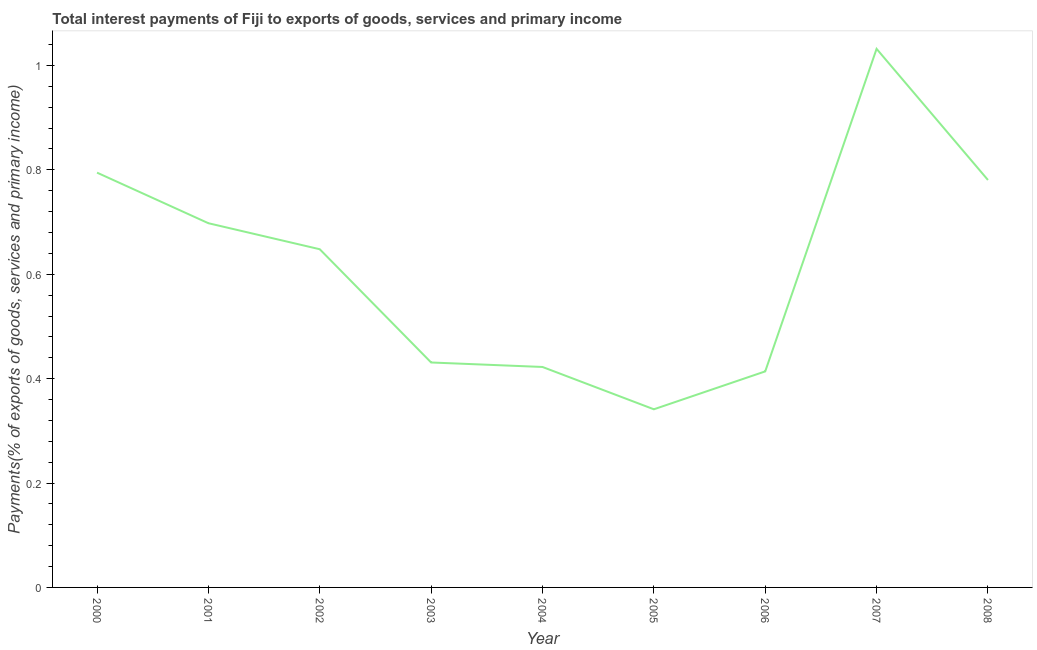What is the total interest payments on external debt in 2006?
Provide a short and direct response. 0.41. Across all years, what is the maximum total interest payments on external debt?
Provide a succinct answer. 1.03. Across all years, what is the minimum total interest payments on external debt?
Your answer should be very brief. 0.34. In which year was the total interest payments on external debt maximum?
Your response must be concise. 2007. In which year was the total interest payments on external debt minimum?
Give a very brief answer. 2005. What is the sum of the total interest payments on external debt?
Make the answer very short. 5.56. What is the difference between the total interest payments on external debt in 2000 and 2004?
Offer a terse response. 0.37. What is the average total interest payments on external debt per year?
Your answer should be compact. 0.62. What is the median total interest payments on external debt?
Offer a terse response. 0.65. What is the ratio of the total interest payments on external debt in 2000 to that in 2004?
Offer a terse response. 1.88. Is the difference between the total interest payments on external debt in 2001 and 2002 greater than the difference between any two years?
Your response must be concise. No. What is the difference between the highest and the second highest total interest payments on external debt?
Give a very brief answer. 0.24. What is the difference between the highest and the lowest total interest payments on external debt?
Keep it short and to the point. 0.69. In how many years, is the total interest payments on external debt greater than the average total interest payments on external debt taken over all years?
Provide a short and direct response. 5. How many lines are there?
Offer a terse response. 1. What is the difference between two consecutive major ticks on the Y-axis?
Your answer should be very brief. 0.2. Are the values on the major ticks of Y-axis written in scientific E-notation?
Provide a succinct answer. No. Does the graph contain any zero values?
Provide a short and direct response. No. Does the graph contain grids?
Ensure brevity in your answer.  No. What is the title of the graph?
Your answer should be very brief. Total interest payments of Fiji to exports of goods, services and primary income. What is the label or title of the Y-axis?
Your answer should be compact. Payments(% of exports of goods, services and primary income). What is the Payments(% of exports of goods, services and primary income) of 2000?
Your response must be concise. 0.79. What is the Payments(% of exports of goods, services and primary income) in 2001?
Provide a succinct answer. 0.7. What is the Payments(% of exports of goods, services and primary income) of 2002?
Your response must be concise. 0.65. What is the Payments(% of exports of goods, services and primary income) in 2003?
Provide a short and direct response. 0.43. What is the Payments(% of exports of goods, services and primary income) of 2004?
Provide a succinct answer. 0.42. What is the Payments(% of exports of goods, services and primary income) of 2005?
Your answer should be very brief. 0.34. What is the Payments(% of exports of goods, services and primary income) in 2006?
Keep it short and to the point. 0.41. What is the Payments(% of exports of goods, services and primary income) of 2007?
Your answer should be very brief. 1.03. What is the Payments(% of exports of goods, services and primary income) of 2008?
Make the answer very short. 0.78. What is the difference between the Payments(% of exports of goods, services and primary income) in 2000 and 2001?
Provide a succinct answer. 0.1. What is the difference between the Payments(% of exports of goods, services and primary income) in 2000 and 2002?
Provide a succinct answer. 0.15. What is the difference between the Payments(% of exports of goods, services and primary income) in 2000 and 2003?
Your response must be concise. 0.36. What is the difference between the Payments(% of exports of goods, services and primary income) in 2000 and 2004?
Your response must be concise. 0.37. What is the difference between the Payments(% of exports of goods, services and primary income) in 2000 and 2005?
Give a very brief answer. 0.45. What is the difference between the Payments(% of exports of goods, services and primary income) in 2000 and 2006?
Provide a succinct answer. 0.38. What is the difference between the Payments(% of exports of goods, services and primary income) in 2000 and 2007?
Your answer should be compact. -0.24. What is the difference between the Payments(% of exports of goods, services and primary income) in 2000 and 2008?
Keep it short and to the point. 0.01. What is the difference between the Payments(% of exports of goods, services and primary income) in 2001 and 2002?
Keep it short and to the point. 0.05. What is the difference between the Payments(% of exports of goods, services and primary income) in 2001 and 2003?
Offer a terse response. 0.27. What is the difference between the Payments(% of exports of goods, services and primary income) in 2001 and 2004?
Offer a terse response. 0.28. What is the difference between the Payments(% of exports of goods, services and primary income) in 2001 and 2005?
Offer a very short reply. 0.36. What is the difference between the Payments(% of exports of goods, services and primary income) in 2001 and 2006?
Provide a short and direct response. 0.28. What is the difference between the Payments(% of exports of goods, services and primary income) in 2001 and 2007?
Make the answer very short. -0.33. What is the difference between the Payments(% of exports of goods, services and primary income) in 2001 and 2008?
Offer a very short reply. -0.08. What is the difference between the Payments(% of exports of goods, services and primary income) in 2002 and 2003?
Make the answer very short. 0.22. What is the difference between the Payments(% of exports of goods, services and primary income) in 2002 and 2004?
Provide a succinct answer. 0.23. What is the difference between the Payments(% of exports of goods, services and primary income) in 2002 and 2005?
Your answer should be compact. 0.31. What is the difference between the Payments(% of exports of goods, services and primary income) in 2002 and 2006?
Your answer should be very brief. 0.23. What is the difference between the Payments(% of exports of goods, services and primary income) in 2002 and 2007?
Your answer should be very brief. -0.38. What is the difference between the Payments(% of exports of goods, services and primary income) in 2002 and 2008?
Make the answer very short. -0.13. What is the difference between the Payments(% of exports of goods, services and primary income) in 2003 and 2004?
Your answer should be compact. 0.01. What is the difference between the Payments(% of exports of goods, services and primary income) in 2003 and 2005?
Give a very brief answer. 0.09. What is the difference between the Payments(% of exports of goods, services and primary income) in 2003 and 2006?
Give a very brief answer. 0.02. What is the difference between the Payments(% of exports of goods, services and primary income) in 2003 and 2007?
Your response must be concise. -0.6. What is the difference between the Payments(% of exports of goods, services and primary income) in 2003 and 2008?
Give a very brief answer. -0.35. What is the difference between the Payments(% of exports of goods, services and primary income) in 2004 and 2005?
Your answer should be compact. 0.08. What is the difference between the Payments(% of exports of goods, services and primary income) in 2004 and 2006?
Ensure brevity in your answer.  0.01. What is the difference between the Payments(% of exports of goods, services and primary income) in 2004 and 2007?
Provide a succinct answer. -0.61. What is the difference between the Payments(% of exports of goods, services and primary income) in 2004 and 2008?
Provide a short and direct response. -0.36. What is the difference between the Payments(% of exports of goods, services and primary income) in 2005 and 2006?
Your response must be concise. -0.07. What is the difference between the Payments(% of exports of goods, services and primary income) in 2005 and 2007?
Your answer should be compact. -0.69. What is the difference between the Payments(% of exports of goods, services and primary income) in 2005 and 2008?
Provide a short and direct response. -0.44. What is the difference between the Payments(% of exports of goods, services and primary income) in 2006 and 2007?
Your response must be concise. -0.62. What is the difference between the Payments(% of exports of goods, services and primary income) in 2006 and 2008?
Give a very brief answer. -0.37. What is the difference between the Payments(% of exports of goods, services and primary income) in 2007 and 2008?
Offer a terse response. 0.25. What is the ratio of the Payments(% of exports of goods, services and primary income) in 2000 to that in 2001?
Provide a succinct answer. 1.14. What is the ratio of the Payments(% of exports of goods, services and primary income) in 2000 to that in 2002?
Keep it short and to the point. 1.23. What is the ratio of the Payments(% of exports of goods, services and primary income) in 2000 to that in 2003?
Give a very brief answer. 1.84. What is the ratio of the Payments(% of exports of goods, services and primary income) in 2000 to that in 2004?
Keep it short and to the point. 1.88. What is the ratio of the Payments(% of exports of goods, services and primary income) in 2000 to that in 2005?
Your answer should be very brief. 2.33. What is the ratio of the Payments(% of exports of goods, services and primary income) in 2000 to that in 2006?
Keep it short and to the point. 1.92. What is the ratio of the Payments(% of exports of goods, services and primary income) in 2000 to that in 2007?
Keep it short and to the point. 0.77. What is the ratio of the Payments(% of exports of goods, services and primary income) in 2001 to that in 2002?
Keep it short and to the point. 1.08. What is the ratio of the Payments(% of exports of goods, services and primary income) in 2001 to that in 2003?
Offer a very short reply. 1.62. What is the ratio of the Payments(% of exports of goods, services and primary income) in 2001 to that in 2004?
Offer a terse response. 1.65. What is the ratio of the Payments(% of exports of goods, services and primary income) in 2001 to that in 2005?
Give a very brief answer. 2.04. What is the ratio of the Payments(% of exports of goods, services and primary income) in 2001 to that in 2006?
Provide a succinct answer. 1.69. What is the ratio of the Payments(% of exports of goods, services and primary income) in 2001 to that in 2007?
Keep it short and to the point. 0.68. What is the ratio of the Payments(% of exports of goods, services and primary income) in 2001 to that in 2008?
Ensure brevity in your answer.  0.89. What is the ratio of the Payments(% of exports of goods, services and primary income) in 2002 to that in 2003?
Ensure brevity in your answer.  1.5. What is the ratio of the Payments(% of exports of goods, services and primary income) in 2002 to that in 2004?
Keep it short and to the point. 1.53. What is the ratio of the Payments(% of exports of goods, services and primary income) in 2002 to that in 2005?
Keep it short and to the point. 1.9. What is the ratio of the Payments(% of exports of goods, services and primary income) in 2002 to that in 2006?
Provide a succinct answer. 1.56. What is the ratio of the Payments(% of exports of goods, services and primary income) in 2002 to that in 2007?
Your answer should be compact. 0.63. What is the ratio of the Payments(% of exports of goods, services and primary income) in 2002 to that in 2008?
Give a very brief answer. 0.83. What is the ratio of the Payments(% of exports of goods, services and primary income) in 2003 to that in 2004?
Keep it short and to the point. 1.02. What is the ratio of the Payments(% of exports of goods, services and primary income) in 2003 to that in 2005?
Provide a short and direct response. 1.26. What is the ratio of the Payments(% of exports of goods, services and primary income) in 2003 to that in 2006?
Offer a terse response. 1.04. What is the ratio of the Payments(% of exports of goods, services and primary income) in 2003 to that in 2007?
Offer a terse response. 0.42. What is the ratio of the Payments(% of exports of goods, services and primary income) in 2003 to that in 2008?
Provide a short and direct response. 0.55. What is the ratio of the Payments(% of exports of goods, services and primary income) in 2004 to that in 2005?
Ensure brevity in your answer.  1.24. What is the ratio of the Payments(% of exports of goods, services and primary income) in 2004 to that in 2006?
Ensure brevity in your answer.  1.02. What is the ratio of the Payments(% of exports of goods, services and primary income) in 2004 to that in 2007?
Ensure brevity in your answer.  0.41. What is the ratio of the Payments(% of exports of goods, services and primary income) in 2004 to that in 2008?
Provide a short and direct response. 0.54. What is the ratio of the Payments(% of exports of goods, services and primary income) in 2005 to that in 2006?
Your answer should be compact. 0.82. What is the ratio of the Payments(% of exports of goods, services and primary income) in 2005 to that in 2007?
Give a very brief answer. 0.33. What is the ratio of the Payments(% of exports of goods, services and primary income) in 2005 to that in 2008?
Offer a terse response. 0.44. What is the ratio of the Payments(% of exports of goods, services and primary income) in 2006 to that in 2007?
Make the answer very short. 0.4. What is the ratio of the Payments(% of exports of goods, services and primary income) in 2006 to that in 2008?
Provide a succinct answer. 0.53. What is the ratio of the Payments(% of exports of goods, services and primary income) in 2007 to that in 2008?
Give a very brief answer. 1.32. 